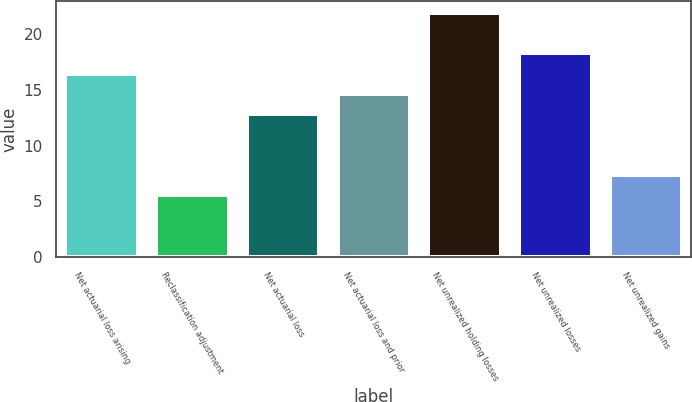<chart> <loc_0><loc_0><loc_500><loc_500><bar_chart><fcel>Net actuarial loss arising<fcel>Reclassification adjustment<fcel>Net actuarial loss<fcel>Net actuarial loss and prior<fcel>Net unrealized holding losses<fcel>Net unrealized losses<fcel>Net unrealized gains<nl><fcel>16.48<fcel>5.56<fcel>12.84<fcel>14.66<fcel>21.94<fcel>18.3<fcel>7.38<nl></chart> 